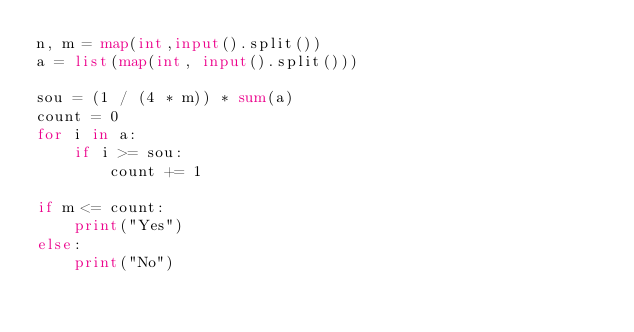<code> <loc_0><loc_0><loc_500><loc_500><_Python_>n, m = map(int,input().split())
a = list(map(int, input().split()))

sou = (1 / (4 * m)) * sum(a)
count = 0
for i in a:
    if i >= sou:
        count += 1

if m <= count:
    print("Yes")
else:
    print("No")</code> 